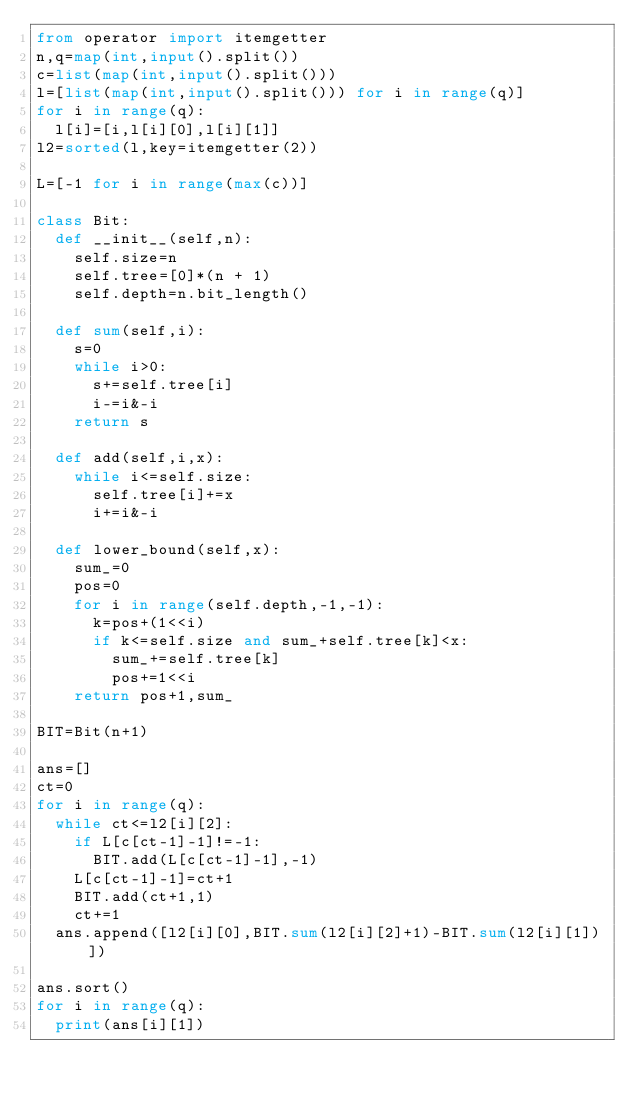Convert code to text. <code><loc_0><loc_0><loc_500><loc_500><_Python_>from operator import itemgetter
n,q=map(int,input().split())
c=list(map(int,input().split()))
l=[list(map(int,input().split())) for i in range(q)]
for i in range(q):
  l[i]=[i,l[i][0],l[i][1]]
l2=sorted(l,key=itemgetter(2))

L=[-1 for i in range(max(c))]

class Bit:
  def __init__(self,n):
    self.size=n
    self.tree=[0]*(n + 1)
    self.depth=n.bit_length()

  def sum(self,i):
    s=0
    while i>0:
      s+=self.tree[i]
      i-=i&-i
    return s

  def add(self,i,x):
    while i<=self.size:
      self.tree[i]+=x
      i+=i&-i
 
  def lower_bound(self,x):
    sum_=0
    pos=0
    for i in range(self.depth,-1,-1):
      k=pos+(1<<i)
      if k<=self.size and sum_+self.tree[k]<x:
        sum_+=self.tree[k]
        pos+=1<<i
    return pos+1,sum_

BIT=Bit(n+1)

ans=[]
ct=0
for i in range(q):
  while ct<=l2[i][2]:
    if L[c[ct-1]-1]!=-1:
      BIT.add(L[c[ct-1]-1],-1)
    L[c[ct-1]-1]=ct+1
    BIT.add(ct+1,1)
    ct+=1
  ans.append([l2[i][0],BIT.sum(l2[i][2]+1)-BIT.sum(l2[i][1])])

ans.sort()
for i in range(q):
  print(ans[i][1])</code> 